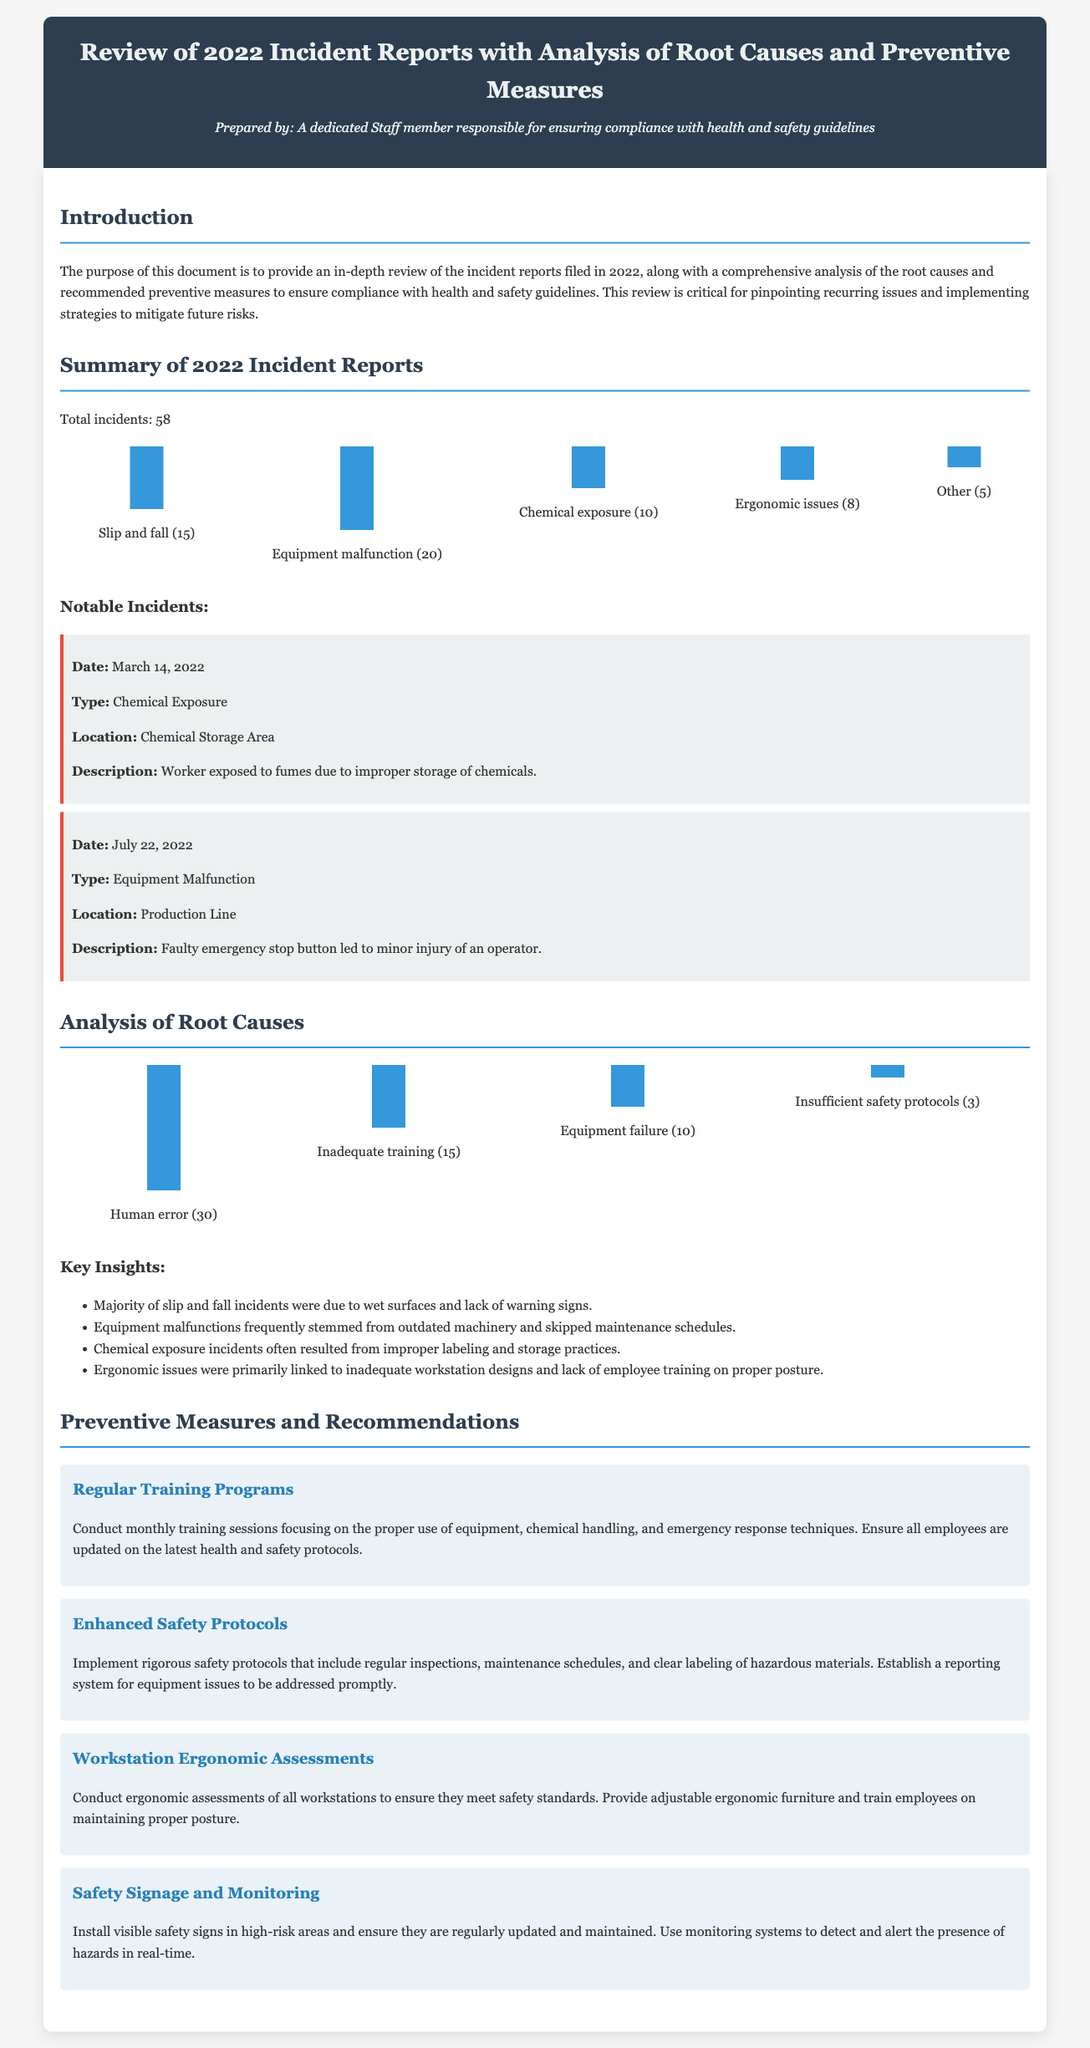What is the total number of incidents reported in 2022? The total number of incidents is explicitly stated in the summary section of the document.
Answer: 58 What was the highest number of incidents caused by equipment malfunction? The document lists the specific incidents of various types, and equipment malfunction has the highest count.
Answer: 20 How many incidents were related to chemical exposure? The document provides the numbers associated with specific types of incidents including chemical exposure.
Answer: 10 What root cause was most frequently reported? The analysis section details the root causes, with human error being the highest.
Answer: Human error When did the notable incident involving chemical exposure occur? The document specifies the date of the notable chemical exposure incident.
Answer: March 14, 2022 What preventive measure focuses on workstation design? The document outlines various preventive measures, one of which addresses workstation ergonomics.
Answer: Workstation Ergonomic Assessments What percentage of incidents were related to inadequate training? The number of incidents listed under inadequate training can be used for this calculation based on the total incidents.
Answer: 25% Which type of incident had the least occurrences? The summary provides a breakdown of incident types, identifying which had the fewest incidents reported.
Answer: Other 